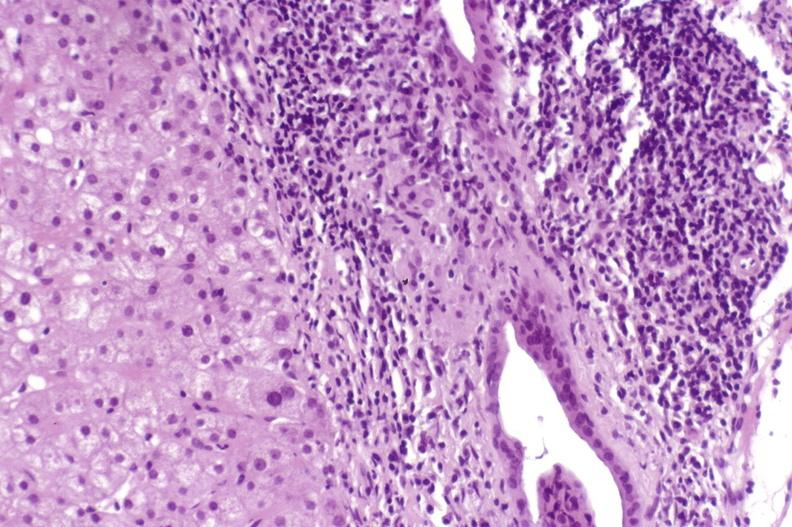what is present?
Answer the question using a single word or phrase. Hepatobiliary 